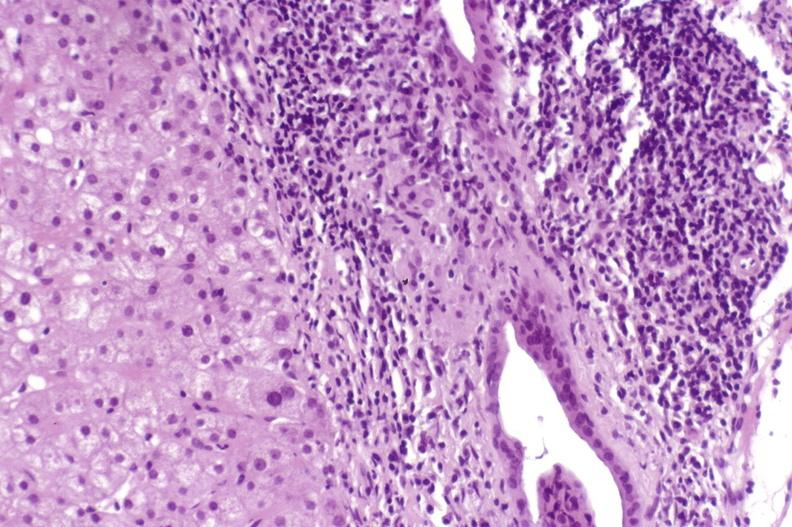what is present?
Answer the question using a single word or phrase. Hepatobiliary 